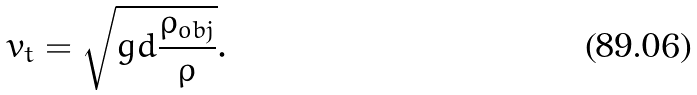<formula> <loc_0><loc_0><loc_500><loc_500>v _ { t } = { \sqrt { g d { \frac { \rho _ { o b j } } { \rho } } } } .</formula> 